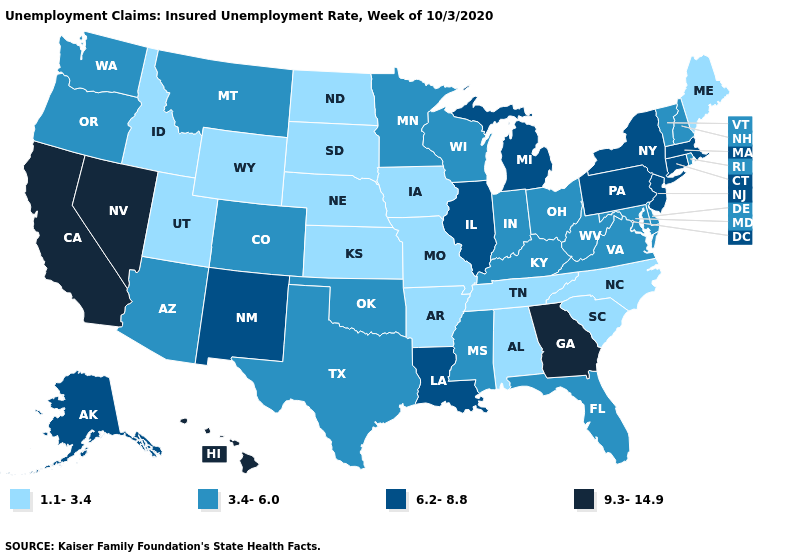Does Hawaii have the lowest value in the USA?
Concise answer only. No. What is the lowest value in the USA?
Give a very brief answer. 1.1-3.4. Which states hav the highest value in the Northeast?
Be succinct. Connecticut, Massachusetts, New Jersey, New York, Pennsylvania. Name the states that have a value in the range 1.1-3.4?
Be succinct. Alabama, Arkansas, Idaho, Iowa, Kansas, Maine, Missouri, Nebraska, North Carolina, North Dakota, South Carolina, South Dakota, Tennessee, Utah, Wyoming. What is the value of Vermont?
Concise answer only. 3.4-6.0. What is the value of North Dakota?
Be succinct. 1.1-3.4. What is the value of Texas?
Keep it brief. 3.4-6.0. Name the states that have a value in the range 1.1-3.4?
Keep it brief. Alabama, Arkansas, Idaho, Iowa, Kansas, Maine, Missouri, Nebraska, North Carolina, North Dakota, South Carolina, South Dakota, Tennessee, Utah, Wyoming. Name the states that have a value in the range 9.3-14.9?
Keep it brief. California, Georgia, Hawaii, Nevada. Which states hav the highest value in the Northeast?
Be succinct. Connecticut, Massachusetts, New Jersey, New York, Pennsylvania. What is the lowest value in the South?
Quick response, please. 1.1-3.4. What is the value of Indiana?
Keep it brief. 3.4-6.0. What is the value of Delaware?
Answer briefly. 3.4-6.0. Does New Jersey have the highest value in the Northeast?
Keep it brief. Yes. What is the highest value in states that border Wyoming?
Concise answer only. 3.4-6.0. 